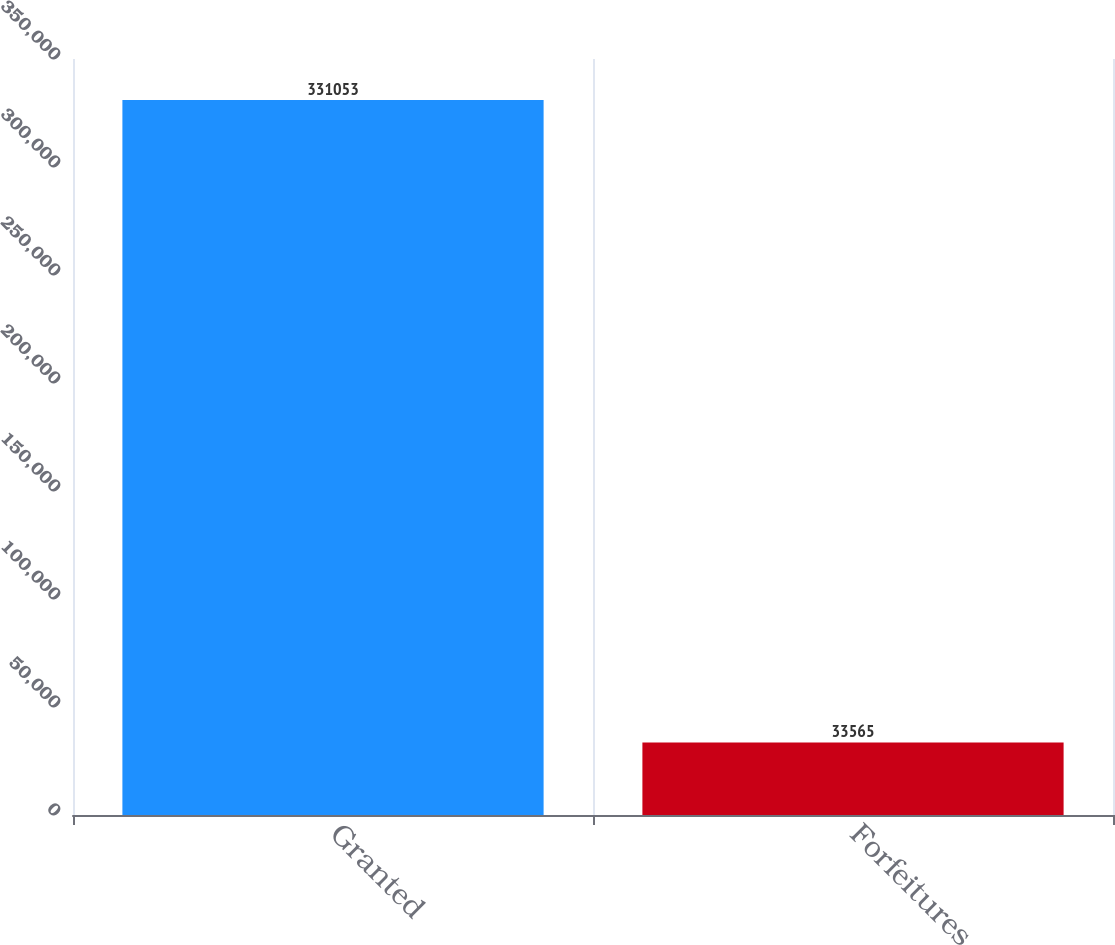Convert chart. <chart><loc_0><loc_0><loc_500><loc_500><bar_chart><fcel>Granted<fcel>Forfeitures<nl><fcel>331053<fcel>33565<nl></chart> 